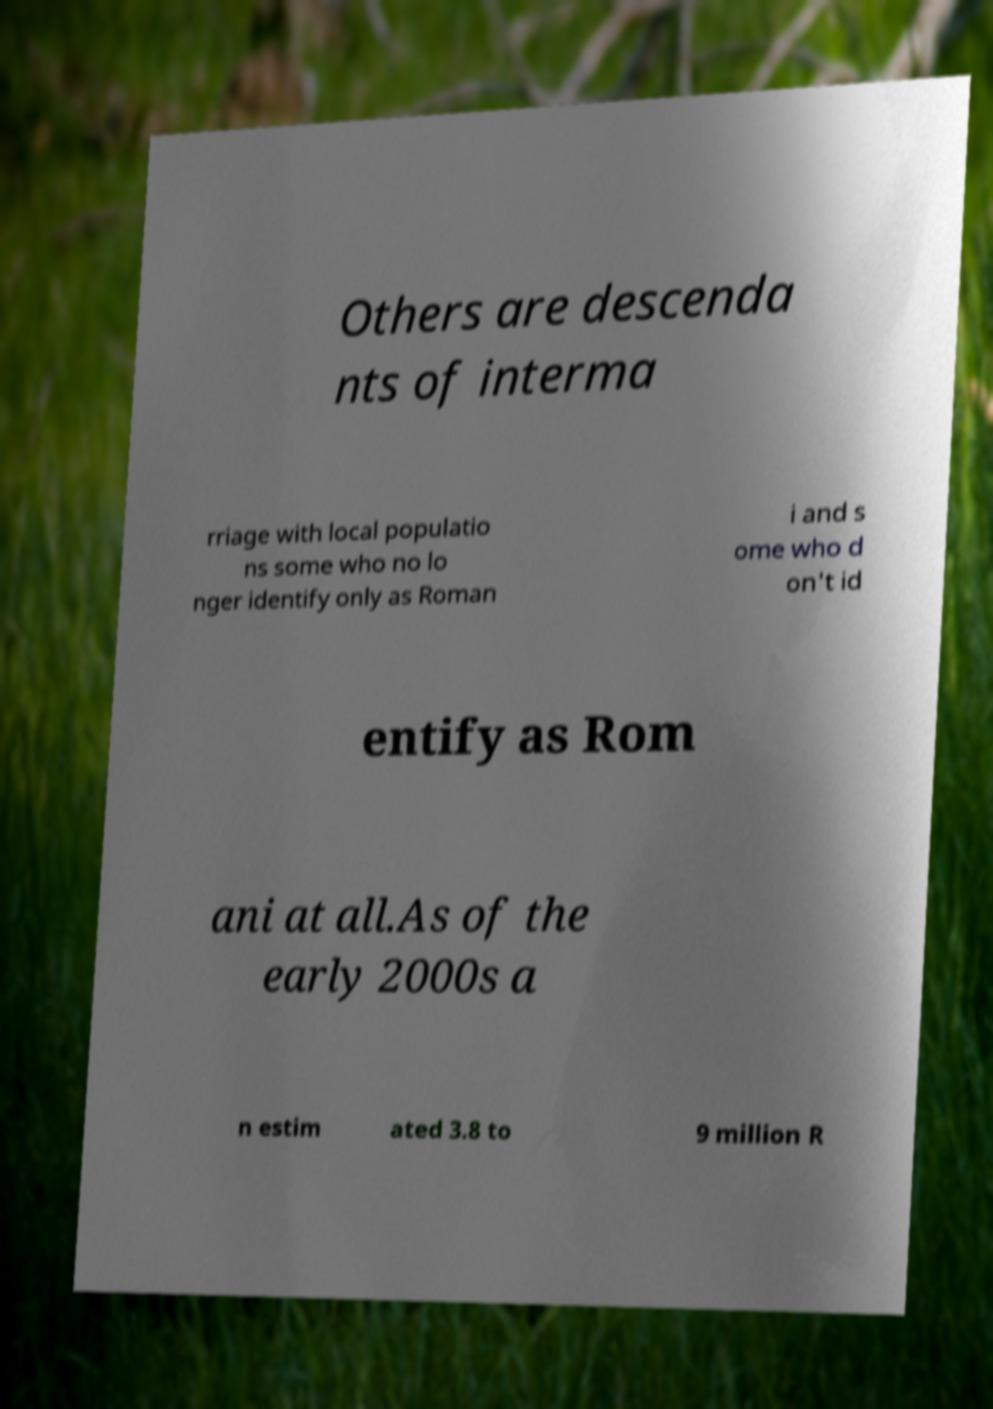Can you accurately transcribe the text from the provided image for me? Others are descenda nts of interma rriage with local populatio ns some who no lo nger identify only as Roman i and s ome who d on't id entify as Rom ani at all.As of the early 2000s a n estim ated 3.8 to 9 million R 